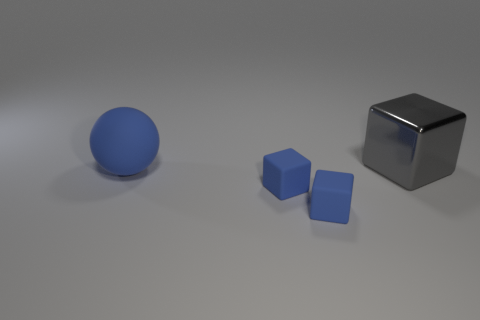There is a big object that is in front of the block behind the big sphere; what is its shape? The big object in question appears to be a cube. It is positioned in front of a block, which seems to be placed behind the large sphere in view. 